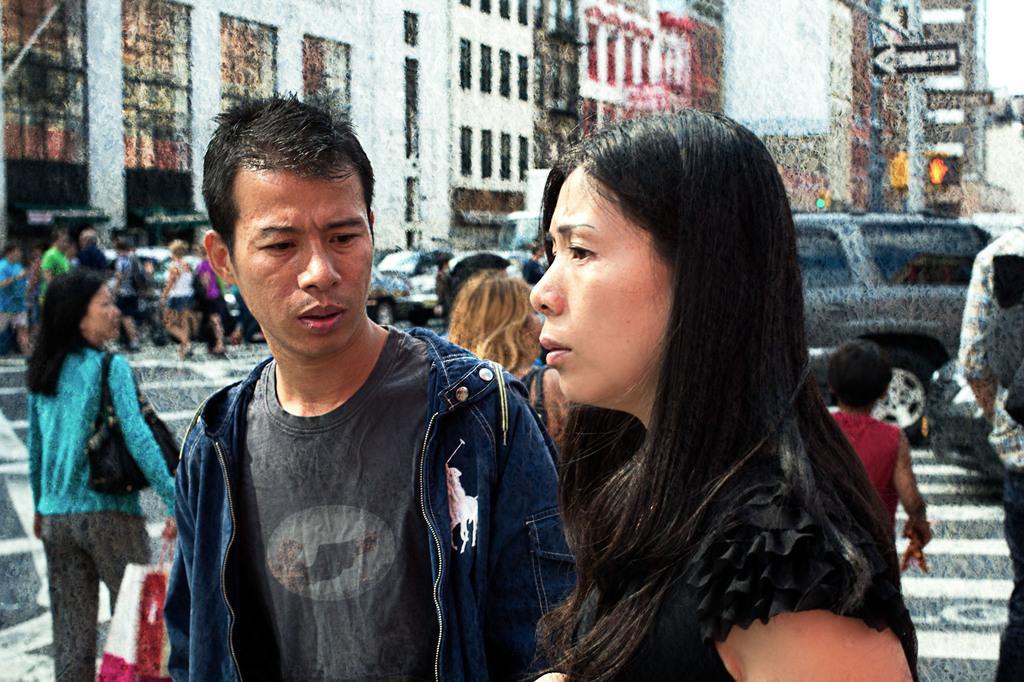Can you describe this image briefly? Here we can see two people. This man is looking at this woman. Background we can see people, buildings, signboards and vehicles. 